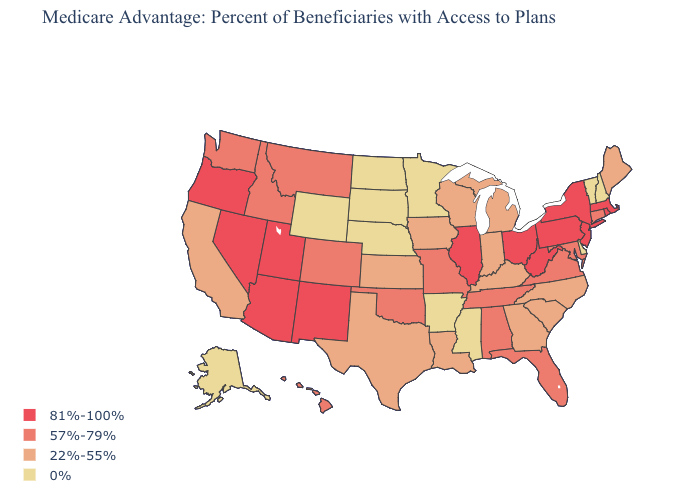What is the highest value in states that border Connecticut?
Give a very brief answer. 81%-100%. Which states have the lowest value in the USA?
Quick response, please. Alaska, Arkansas, Delaware, Minnesota, Mississippi, North Dakota, Nebraska, New Hampshire, South Dakota, Vermont, Wyoming. Among the states that border New Mexico , does Arizona have the lowest value?
Answer briefly. No. Does the first symbol in the legend represent the smallest category?
Keep it brief. No. What is the value of Connecticut?
Answer briefly. 57%-79%. What is the value of Maryland?
Quick response, please. 57%-79%. What is the highest value in the USA?
Answer briefly. 81%-100%. What is the highest value in the Northeast ?
Answer briefly. 81%-100%. What is the lowest value in states that border Washington?
Write a very short answer. 57%-79%. What is the value of North Carolina?
Answer briefly. 22%-55%. What is the lowest value in the USA?
Short answer required. 0%. What is the value of Florida?
Short answer required. 57%-79%. Among the states that border Kentucky , which have the lowest value?
Give a very brief answer. Indiana. Is the legend a continuous bar?
Short answer required. No. Name the states that have a value in the range 81%-100%?
Give a very brief answer. Arizona, Illinois, Massachusetts, New Jersey, New Mexico, Nevada, New York, Ohio, Oregon, Pennsylvania, Rhode Island, Utah, West Virginia. 